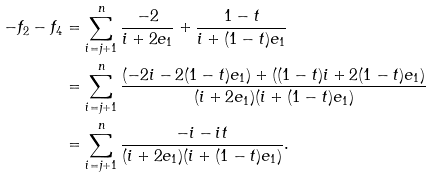<formula> <loc_0><loc_0><loc_500><loc_500>- f _ { 2 } - f _ { 4 } & = \sum _ { i = j + 1 } ^ { n } \frac { - 2 } { i + 2 e _ { 1 } } + \frac { 1 - t } { i + ( 1 - t ) e _ { 1 } } \\ & = \sum _ { i = j + 1 } ^ { n } \frac { \left ( - 2 i - 2 ( 1 - t ) e _ { 1 } \right ) + \left ( ( 1 - t ) i + 2 ( 1 - t ) e _ { 1 } \right ) } { ( i + 2 e _ { 1 } ) ( i + ( 1 - t ) e _ { 1 } ) } \\ & = \sum _ { i = j + 1 } ^ { n } \frac { - i - i t } { ( i + 2 e _ { 1 } ) ( i + ( 1 - t ) e _ { 1 } ) } .</formula> 